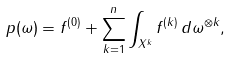Convert formula to latex. <formula><loc_0><loc_0><loc_500><loc_500>p ( \omega ) = f ^ { ( 0 ) } + \sum _ { k = 1 } ^ { n } \int _ { X ^ { k } } f ^ { ( k ) } \, d \omega ^ { \otimes k } ,</formula> 